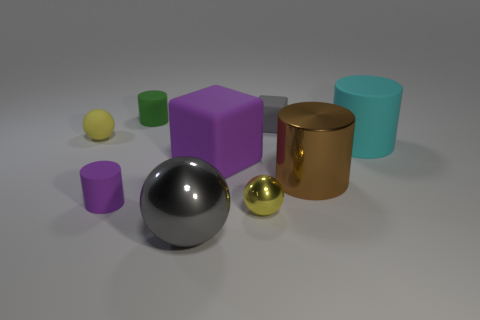Subtract all large metal cylinders. How many cylinders are left? 3 Subtract all brown cubes. How many yellow spheres are left? 2 Add 1 yellow balls. How many objects exist? 10 Subtract all cylinders. How many objects are left? 5 Subtract all gray balls. How many balls are left? 2 Subtract all big matte objects. Subtract all brown cylinders. How many objects are left? 6 Add 9 purple cubes. How many purple cubes are left? 10 Add 8 small green matte cylinders. How many small green matte cylinders exist? 9 Subtract 1 gray blocks. How many objects are left? 8 Subtract all gray cubes. Subtract all cyan balls. How many cubes are left? 1 